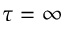<formula> <loc_0><loc_0><loc_500><loc_500>\tau = \infty</formula> 